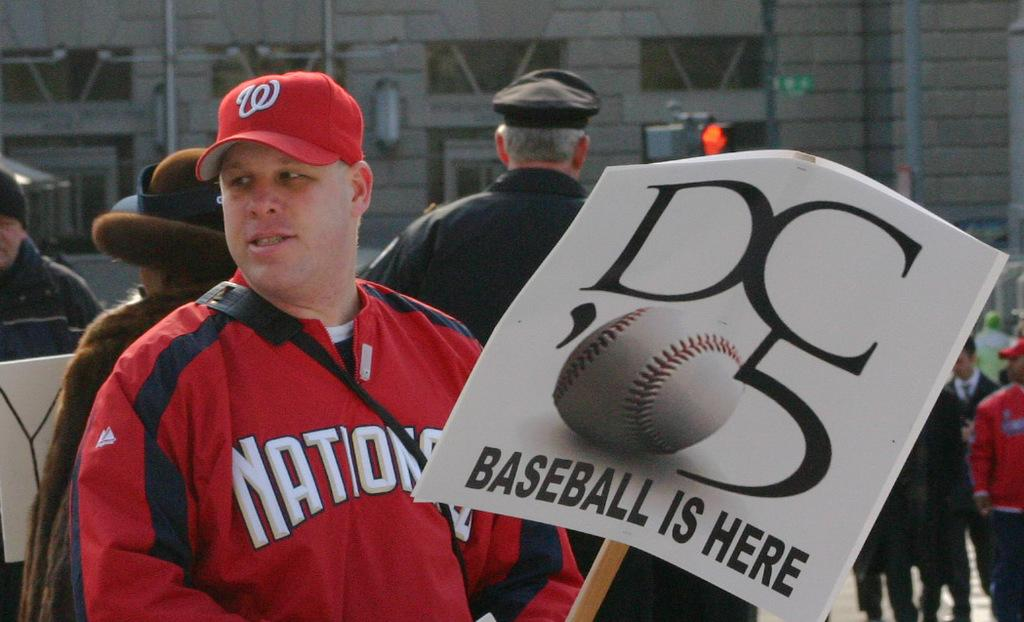Provide a one-sentence caption for the provided image. A man wearing a red cap and jacket holds a placard which tells us DC 05 baseball is here. 